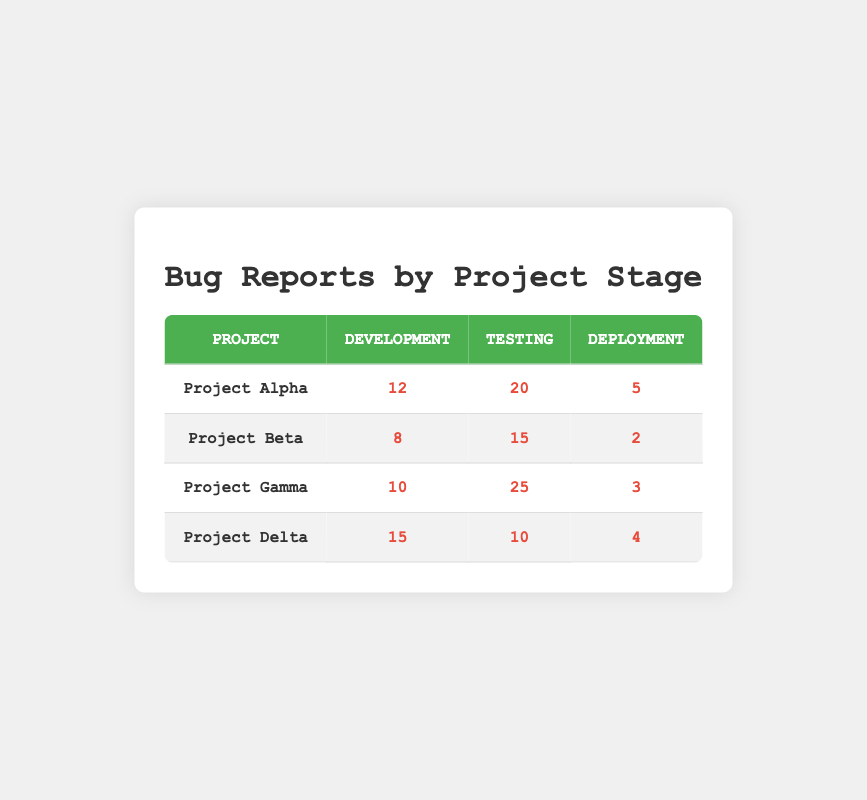What is the total number of bug reports for Project Alpha? To find the total number of bug reports for Project Alpha, I need to sum the bug reports across all stages (Development, Testing, Deployment): 12 + 20 + 5 = 37.
Answer: 37 Which project experienced the highest number of bug reports during the Testing phase? Looking at the Testing column, Project Gamma has the highest number of bug reports with 25, compared to Project Alpha (20), Project Beta (15), and Project Delta (10).
Answer: Project Gamma What is the average number of bug reports during the Development stage across all projects? To find the average, I sum the bug reports in the Development stage: (12 + 8 + 10 + 15) = 45. There are 4 projects, so the average is 45 / 4 = 11.25.
Answer: 11.25 Did any project generate the same number of bug reports in both the Development and Deployment stages? I check each project to see if the numbers match: Project Alpha (12 vs 5), Project Beta (8 vs 2), Project Gamma (10 vs 3), and Project Delta (15 vs 4). None of the projects have matching numbers.
Answer: No What is the difference in bug reports between the Testing stage of Project Gamma and Project Delta? The bug reports for Project Gamma in Testing is 25, while for Project Delta it is 10. The difference is 25 - 10 = 15.
Answer: 15 Which project has the least number of bug reports in the Deployment stage? By checking the Deployment column, Project Beta has the least number of bug reports with 2, while Project Alpha has 5, Project Gamma has 3, and Project Delta has 4.
Answer: Project Beta What is the total number of bug reports for all projects during the Development stage? Adding the bug reports in the Development stage: 12 (Alpha) + 8 (Beta) + 10 (Gamma) + 15 (Delta) = 45.
Answer: 45 Is there any project that has fewer bug reports during Deployment than during Development? Analyzing each project: Project Alpha (5 vs 12), Project Beta (2 vs 8), Project Gamma (3 vs 10), Project Delta (4 vs 15) shows that all projects have fewer bug reports in Deployment than in Development.
Answer: Yes What is the median number of bug reports for the Testing stage across all projects? The counts in the Testing stage are: 20 (Alpha), 15 (Beta), 25 (Gamma), and 10 (Delta). Arranging them in order: 10, 15, 20, 25. The median is the average of the two middle numbers (15 and 20), which is (15 + 20) / 2 = 17.5.
Answer: 17.5 